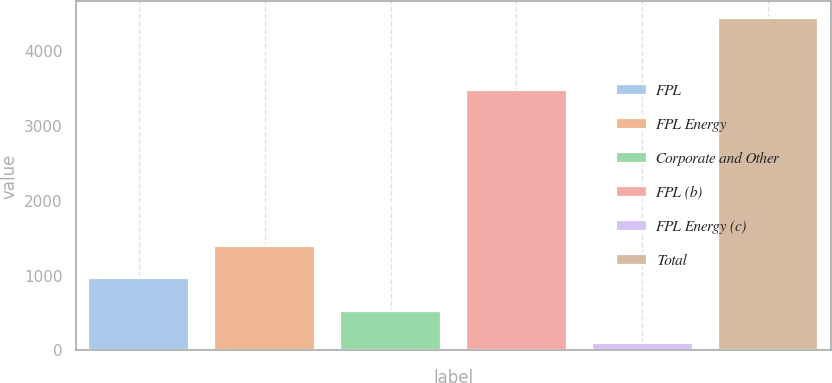Convert chart. <chart><loc_0><loc_0><loc_500><loc_500><bar_chart><fcel>FPL<fcel>FPL Energy<fcel>Corporate and Other<fcel>FPL (b)<fcel>FPL Energy (c)<fcel>Total<nl><fcel>964.6<fcel>1399.9<fcel>529.3<fcel>3480<fcel>94<fcel>4447<nl></chart> 